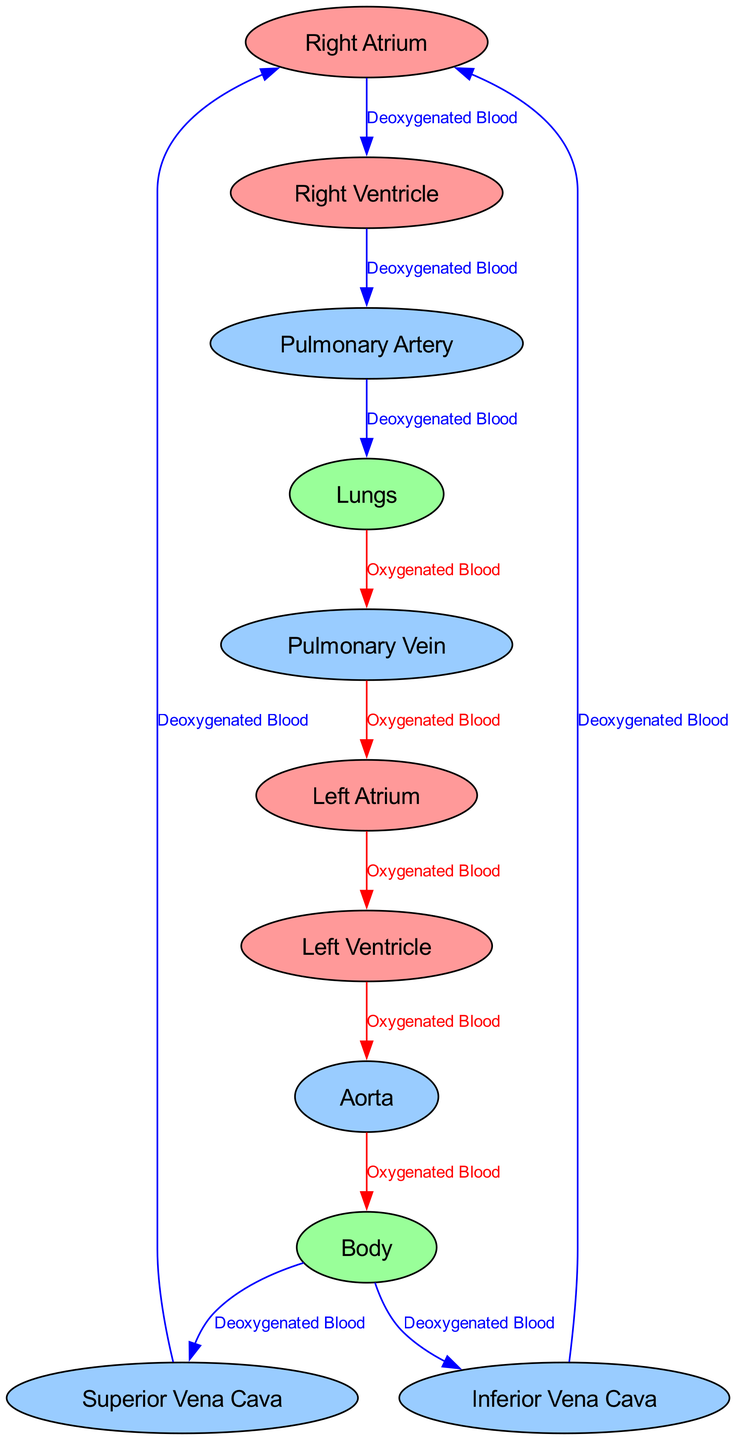What is the starting point of deoxygenated blood in the circulatory system? Deoxygenated blood enters the circulatory system from the body via the superior and inferior vena cavae. Both veins feed into the right atrium, which is the starting point for deoxygenated blood.
Answer: Right Atrium How many major blood vessels are indicated in the diagram? The diagram identifies five major blood vessels: the superior vena cava, inferior vena cava, pulmonary artery, pulmonary vein, and aorta. Counting these gives us a total of five vessels.
Answer: Five Which chamber of the heart receives oxygenated blood from the lungs? After passing through the lungs, oxygenated blood travels through the pulmonary vein and enters the left atrium, making it the chamber that receives oxygenated blood.
Answer: Left Atrium What type of blood flows through the aorta? The aorta carries oxygenated blood that has been pumped from the left ventricle to the body. Therefore, it primarily contains oxygenated blood.
Answer: Oxygenated Blood Trace the path of deoxygenated blood from the body to the lungs. Deoxygenated blood flows from the body into the superior and inferior vena cavae, then into the right atrium, passing through the right ventricle to the pulmonary artery, which leads to the lungs. This sequence outlines the full path taken.
Answer: Body → Superior Vena Cava / Inferior Vena Cava → Right Atrium → Right Ventricle → Pulmonary Artery → Lungs How many atria are present in the diagram? The diagram shows two atria: the right atrium and left atrium, representing the upper chambers of the heart. By counting these, we find there are two atria.
Answer: Two What is the flow direction of oxygenated blood after it leaves the left ventricle? Once the left ventricle pumps oxygenated blood, it enters the aorta, flowing outward to supply blood to the entire body. Thus, the flow direction of oxygenated blood post-left ventricle is towards the body.
Answer: Aorta Which node is directly connected to the pulmonary vein? The pulmonary vein connects directly to the left atrium, indicating its immediate relationship with this chamber of the heart. Thus, the left atrium is the node in question.
Answer: Left Atrium What type of blood is carried by the pulmonary artery? The pulmonary artery carries deoxygenated blood from the right ventricle to the lungs for oxygenation. Therefore, the blood type in the pulmonary artery is deoxygenated.
Answer: Deoxygenated Blood 